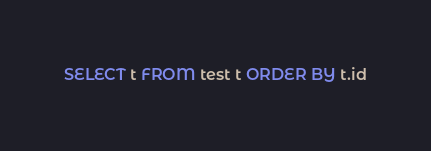Convert code to text. <code><loc_0><loc_0><loc_500><loc_500><_SQL_>SELECT t FROM test t ORDER BY t.id
</code> 